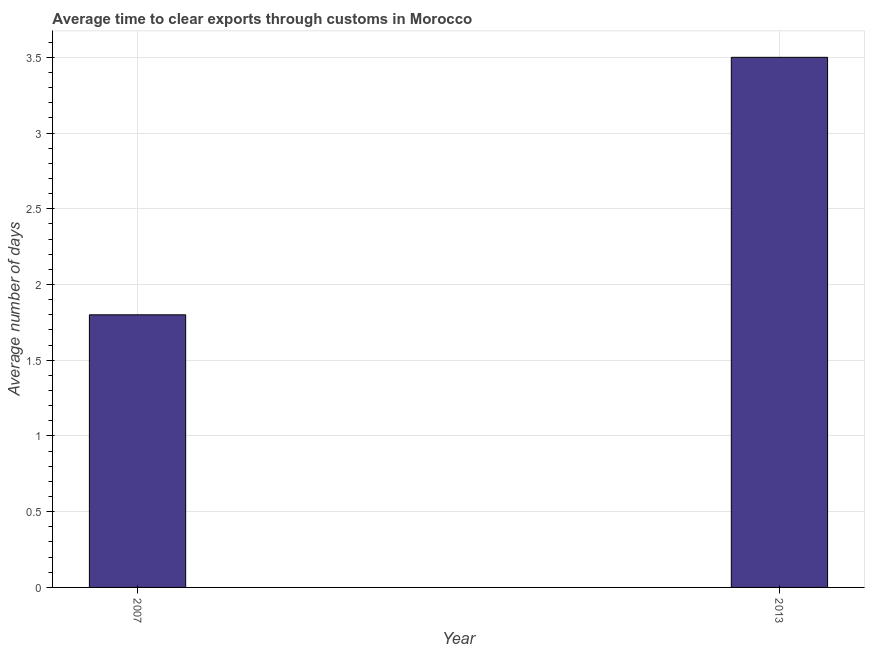Does the graph contain any zero values?
Your answer should be very brief. No. Does the graph contain grids?
Provide a short and direct response. Yes. What is the title of the graph?
Ensure brevity in your answer.  Average time to clear exports through customs in Morocco. What is the label or title of the Y-axis?
Your response must be concise. Average number of days. Across all years, what is the maximum time to clear exports through customs?
Your answer should be compact. 3.5. Across all years, what is the minimum time to clear exports through customs?
Keep it short and to the point. 1.8. In which year was the time to clear exports through customs maximum?
Provide a short and direct response. 2013. What is the difference between the time to clear exports through customs in 2007 and 2013?
Your answer should be very brief. -1.7. What is the average time to clear exports through customs per year?
Your answer should be very brief. 2.65. What is the median time to clear exports through customs?
Your response must be concise. 2.65. What is the ratio of the time to clear exports through customs in 2007 to that in 2013?
Your answer should be compact. 0.51. Is the time to clear exports through customs in 2007 less than that in 2013?
Your answer should be very brief. Yes. In how many years, is the time to clear exports through customs greater than the average time to clear exports through customs taken over all years?
Your response must be concise. 1. What is the difference between two consecutive major ticks on the Y-axis?
Your response must be concise. 0.5. What is the Average number of days in 2007?
Make the answer very short. 1.8. What is the Average number of days in 2013?
Keep it short and to the point. 3.5. What is the ratio of the Average number of days in 2007 to that in 2013?
Provide a short and direct response. 0.51. 